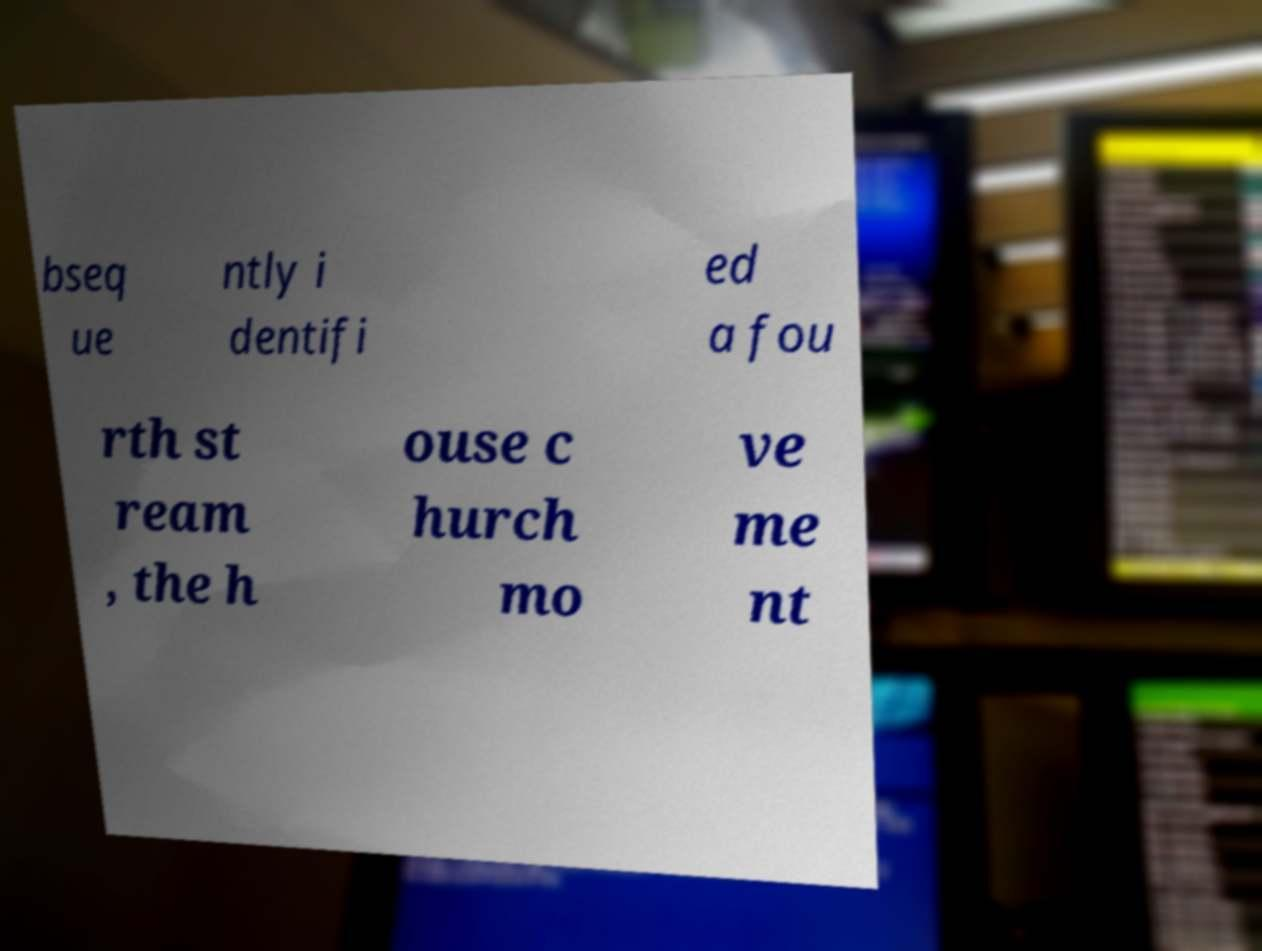I need the written content from this picture converted into text. Can you do that? bseq ue ntly i dentifi ed a fou rth st ream , the h ouse c hurch mo ve me nt 